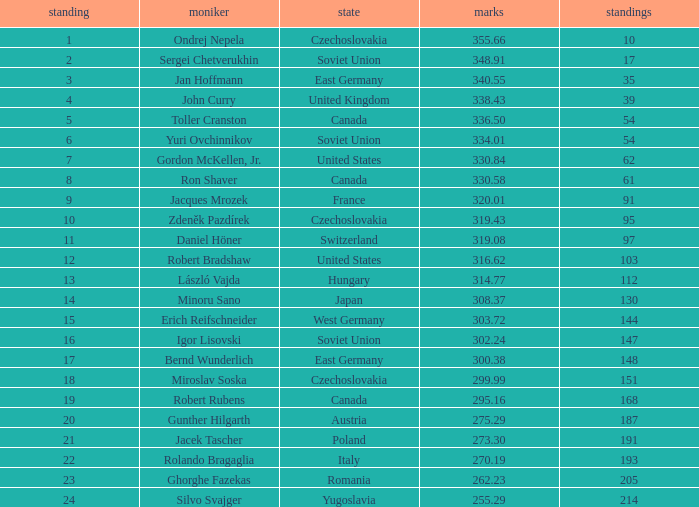Which Nation has Points of 300.38? East Germany. I'm looking to parse the entire table for insights. Could you assist me with that? {'header': ['standing', 'moniker', 'state', 'marks', 'standings'], 'rows': [['1', 'Ondrej Nepela', 'Czechoslovakia', '355.66', '10'], ['2', 'Sergei Chetverukhin', 'Soviet Union', '348.91', '17'], ['3', 'Jan Hoffmann', 'East Germany', '340.55', '35'], ['4', 'John Curry', 'United Kingdom', '338.43', '39'], ['5', 'Toller Cranston', 'Canada', '336.50', '54'], ['6', 'Yuri Ovchinnikov', 'Soviet Union', '334.01', '54'], ['7', 'Gordon McKellen, Jr.', 'United States', '330.84', '62'], ['8', 'Ron Shaver', 'Canada', '330.58', '61'], ['9', 'Jacques Mrozek', 'France', '320.01', '91'], ['10', 'Zdeněk Pazdírek', 'Czechoslovakia', '319.43', '95'], ['11', 'Daniel Höner', 'Switzerland', '319.08', '97'], ['12', 'Robert Bradshaw', 'United States', '316.62', '103'], ['13', 'László Vajda', 'Hungary', '314.77', '112'], ['14', 'Minoru Sano', 'Japan', '308.37', '130'], ['15', 'Erich Reifschneider', 'West Germany', '303.72', '144'], ['16', 'Igor Lisovski', 'Soviet Union', '302.24', '147'], ['17', 'Bernd Wunderlich', 'East Germany', '300.38', '148'], ['18', 'Miroslav Soska', 'Czechoslovakia', '299.99', '151'], ['19', 'Robert Rubens', 'Canada', '295.16', '168'], ['20', 'Gunther Hilgarth', 'Austria', '275.29', '187'], ['21', 'Jacek Tascher', 'Poland', '273.30', '191'], ['22', 'Rolando Bragaglia', 'Italy', '270.19', '193'], ['23', 'Ghorghe Fazekas', 'Romania', '262.23', '205'], ['24', 'Silvo Svajger', 'Yugoslavia', '255.29', '214']]} 